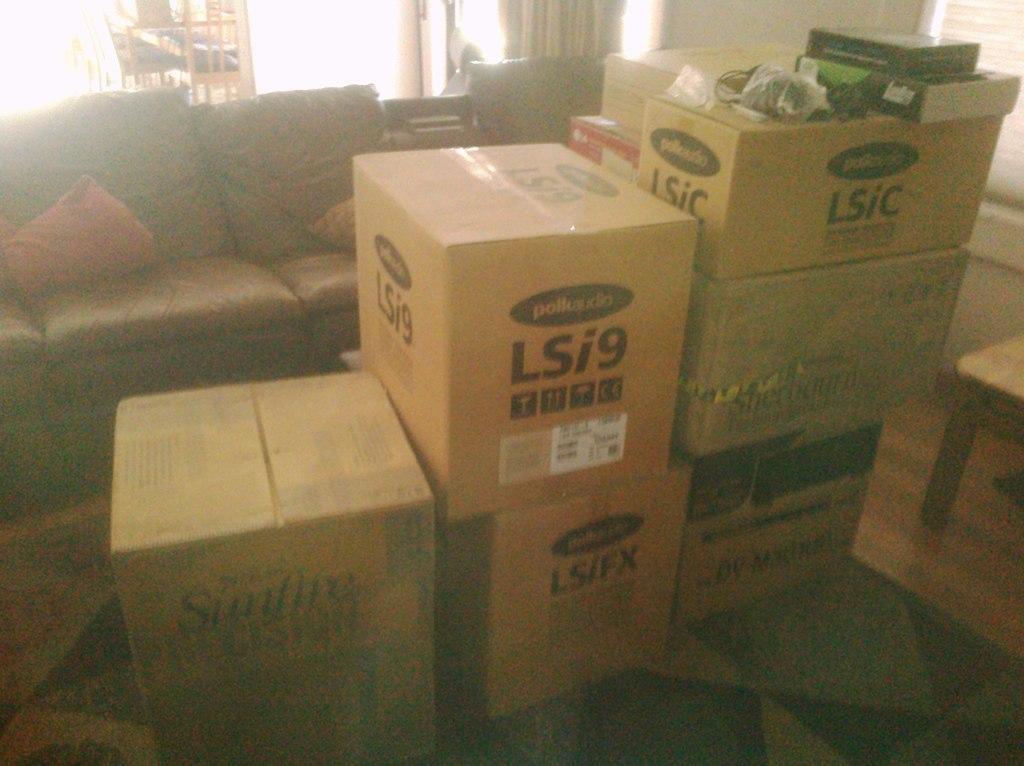Describe this image in one or two sentences. This is a picture taken in a room. In the center of the picture there are many boxes. On the right there is a stool. In the background there is a couch and pillows on it. On the top there is a door and curtain. 